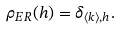<formula> <loc_0><loc_0><loc_500><loc_500>\rho _ { E R } ( h ) = \delta _ { \langle k \rangle , h } .</formula> 